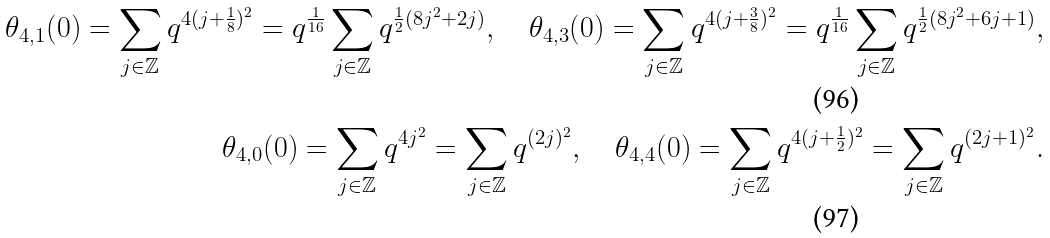<formula> <loc_0><loc_0><loc_500><loc_500>\theta _ { 4 , 1 } ( 0 ) = \sum _ { j \in \mathbb { Z } } q ^ { 4 ( j + \frac { 1 } { 8 } ) ^ { 2 } } = q ^ { \frac { 1 } { 1 6 } } \sum _ { j \in \mathbb { Z } } q ^ { \frac { 1 } { 2 } ( 8 j ^ { 2 } + 2 j ) } , \quad \theta _ { 4 , 3 } ( 0 ) = \sum _ { j \in \mathbb { Z } } q ^ { 4 ( j + \frac { 3 } { 8 } ) ^ { 2 } } = q ^ { \frac { 1 } { 1 6 } } \sum _ { j \in \mathbb { Z } } q ^ { \frac { 1 } { 2 } ( 8 j ^ { 2 } + 6 j + 1 ) } , \\ \theta _ { 4 , 0 } ( 0 ) = \sum _ { j \in \mathbb { Z } } q ^ { 4 j ^ { 2 } } = \sum _ { j \in \mathbb { Z } } q ^ { ( 2 j ) ^ { 2 } } , \quad \theta _ { 4 , 4 } ( 0 ) = \sum _ { j \in \mathbb { Z } } q ^ { 4 ( j + \frac { 1 } { 2 } ) ^ { 2 } } = \sum _ { j \in \mathbb { Z } } q ^ { ( 2 j + 1 ) ^ { 2 } } .</formula> 